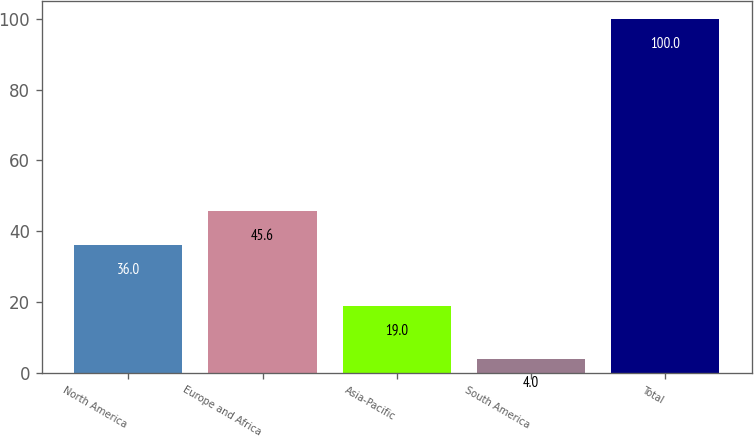Convert chart. <chart><loc_0><loc_0><loc_500><loc_500><bar_chart><fcel>North America<fcel>Europe and Africa<fcel>Asia-Pacific<fcel>South America<fcel>Total<nl><fcel>36<fcel>45.6<fcel>19<fcel>4<fcel>100<nl></chart> 